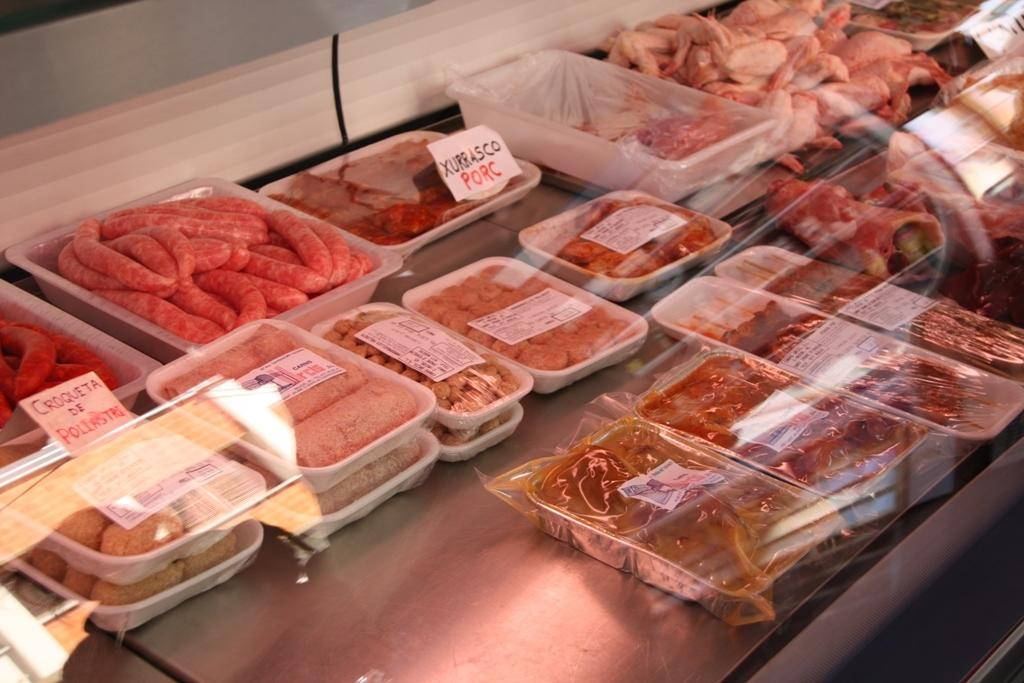What objects are present in the image that are used for storage? There are boxes in the image that are used for storage. What type of items can be seen in the image that are typically used for documentation? There are papers in the image that are typically used for documentation. What can be seen in the image that people consume for nourishment? There are different types of food in the image that people consume for nourishment. What information might be conveyed by the papers in the image? There is writing on the papers in the image, which suggests that they contain information or text. What channel is the television set to in the image? There is no television set present in the image. What number is written on the papers in the image? There is no specific number mentioned in the facts provided, and the image does not show any numbers on the papers. 